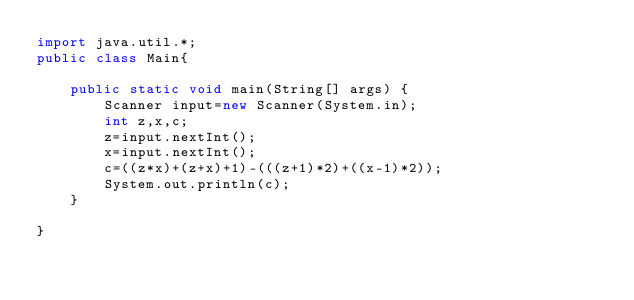<code> <loc_0><loc_0><loc_500><loc_500><_Java_>import java.util.*;
public class Main{

    public static void main(String[] args) {
        Scanner input=new Scanner(System.in);
        int z,x,c;
        z=input.nextInt();
        x=input.nextInt();
        c=((z*x)+(z+x)+1)-(((z+1)*2)+((x-1)*2));
        System.out.println(c);
    }
    
}
</code> 